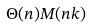<formula> <loc_0><loc_0><loc_500><loc_500>\Theta ( n ) M ( n k )</formula> 